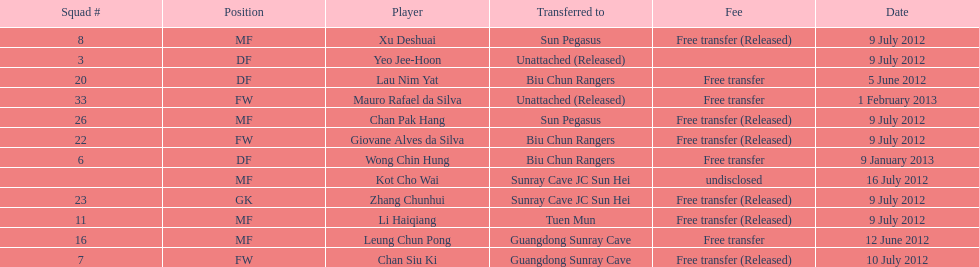Write the full table. {'header': ['Squad #', 'Position', 'Player', 'Transferred to', 'Fee', 'Date'], 'rows': [['8', 'MF', 'Xu Deshuai', 'Sun Pegasus', 'Free transfer (Released)', '9 July 2012'], ['3', 'DF', 'Yeo Jee-Hoon', 'Unattached (Released)', '', '9 July 2012'], ['20', 'DF', 'Lau Nim Yat', 'Biu Chun Rangers', 'Free transfer', '5 June 2012'], ['33', 'FW', 'Mauro Rafael da Silva', 'Unattached (Released)', 'Free transfer', '1 February 2013'], ['26', 'MF', 'Chan Pak Hang', 'Sun Pegasus', 'Free transfer (Released)', '9 July 2012'], ['22', 'FW', 'Giovane Alves da Silva', 'Biu Chun Rangers', 'Free transfer (Released)', '9 July 2012'], ['6', 'DF', 'Wong Chin Hung', 'Biu Chun Rangers', 'Free transfer', '9 January 2013'], ['', 'MF', 'Kot Cho Wai', 'Sunray Cave JC Sun Hei', 'undisclosed', '16 July 2012'], ['23', 'GK', 'Zhang Chunhui', 'Sunray Cave JC Sun Hei', 'Free transfer (Released)', '9 July 2012'], ['11', 'MF', 'Li Haiqiang', 'Tuen Mun', 'Free transfer (Released)', '9 July 2012'], ['16', 'MF', 'Leung Chun Pong', 'Guangdong Sunray Cave', 'Free transfer', '12 June 2012'], ['7', 'FW', 'Chan Siu Ki', 'Guangdong Sunray Cave', 'Free transfer (Released)', '10 July 2012']]} Lau nim yat and giovane alves de silva where both transferred to which team? Biu Chun Rangers. 